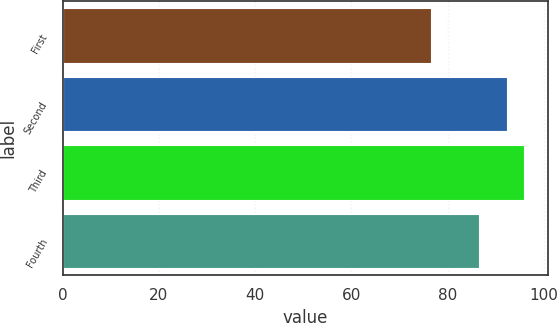<chart> <loc_0><loc_0><loc_500><loc_500><bar_chart><fcel>First<fcel>Second<fcel>Third<fcel>Fourth<nl><fcel>76.5<fcel>92.25<fcel>95.96<fcel>86.61<nl></chart> 